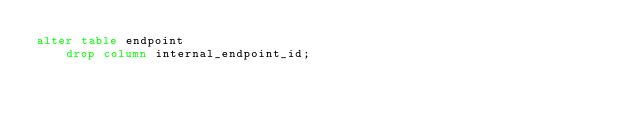Convert code to text. <code><loc_0><loc_0><loc_500><loc_500><_SQL_>alter table endpoint
    drop column internal_endpoint_id;
</code> 